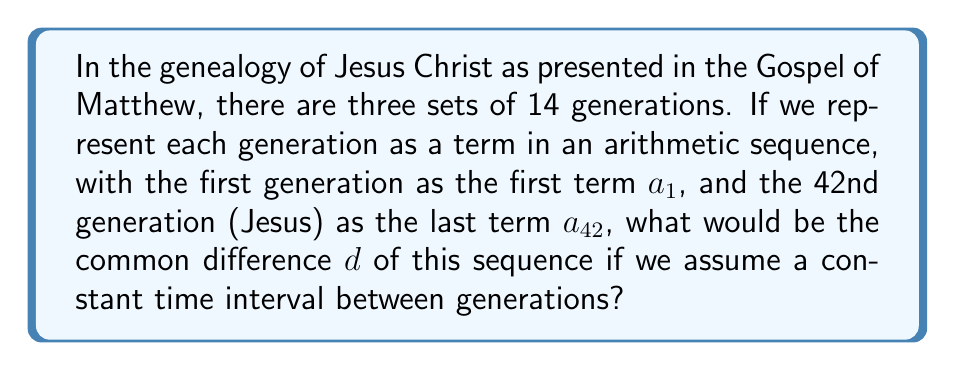Provide a solution to this math problem. Let's approach this step-by-step:

1) In an arithmetic sequence, the general term is given by the formula:
   $a_n = a_1 + (n-1)d$

2) We know that:
   $a_1$ = 1st generation (Abraham)
   $a_{42}$ = 42nd generation (Jesus)

3) We can set up the equation:
   $a_{42} = a_1 + (42-1)d$

4) Let's assume $a_1 = 0$ (representing the start point) and $a_{42} = 41$ (representing the 41 intervals between the 42 generations).

5) Substituting these values:
   $41 = 0 + (41)d$

6) Solving for $d$:
   $41 = 41d$
   $d = 1$

7) This means each generation in the sequence is represented by an increment of 1.

8) We can verify this:
   1st set: $a_1 = 0, a_{14} = 13$
   2nd set: $a_{15} = 14, a_{28} = 27$
   3rd set: $a_{29} = 28, a_{42} = 41$

Thus, the common difference $d$ is 1, representing a constant interval between generations in this biblical genealogy sequence.
Answer: $d = 1$ 